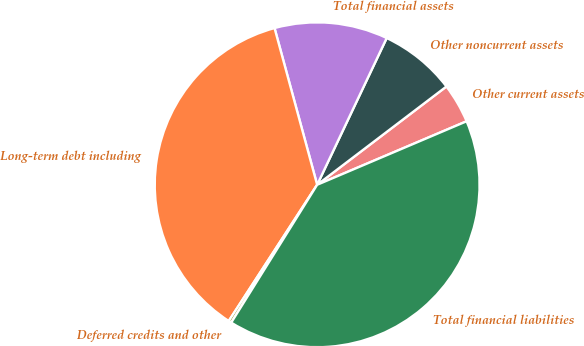Convert chart. <chart><loc_0><loc_0><loc_500><loc_500><pie_chart><fcel>Other current assets<fcel>Other noncurrent assets<fcel>Total financial assets<fcel>Long-term debt including<fcel>Deferred credits and other<fcel>Total financial liabilities<nl><fcel>3.95%<fcel>7.61%<fcel>11.27%<fcel>36.61%<fcel>0.29%<fcel>40.27%<nl></chart> 